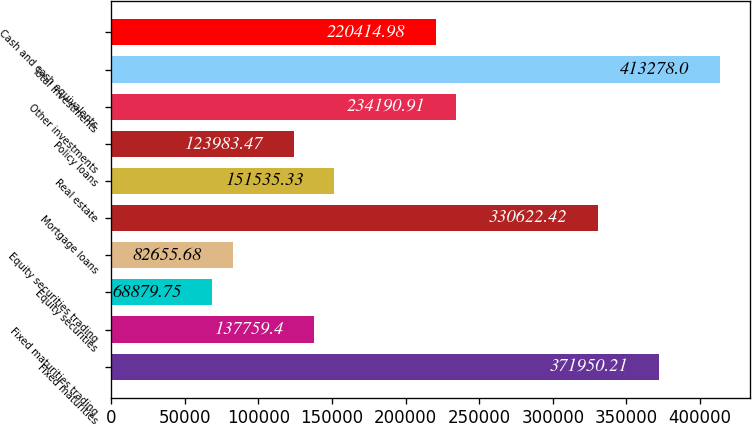<chart> <loc_0><loc_0><loc_500><loc_500><bar_chart><fcel>Fixed maturities<fcel>Fixed maturities trading<fcel>Equity securities<fcel>Equity securities trading<fcel>Mortgage loans<fcel>Real estate<fcel>Policy loans<fcel>Other investments<fcel>Total investments<fcel>Cash and cash equivalents<nl><fcel>371950<fcel>137759<fcel>68879.8<fcel>82655.7<fcel>330622<fcel>151535<fcel>123983<fcel>234191<fcel>413278<fcel>220415<nl></chart> 